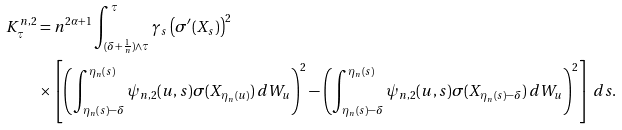Convert formula to latex. <formula><loc_0><loc_0><loc_500><loc_500>K ^ { n , 2 } _ { \tau } & = n ^ { 2 \alpha + 1 } \int ^ { \tau } _ { ( \delta + \frac { 1 } { n } ) \wedge \tau } \gamma _ { s } \left ( \sigma ^ { \prime } ( X _ { s } ) \right ) ^ { 2 } \\ & \times \left [ \left ( \int _ { \eta _ { n } ( s ) - \delta } ^ { \eta _ { n } ( s ) } \psi _ { n , 2 } ( u , s ) \sigma ( X _ { \eta _ { n } ( u ) } ) \, d W _ { u } \right ) ^ { 2 } - \left ( \int _ { \eta _ { n } ( s ) - \delta } ^ { \eta _ { n } ( s ) } \psi _ { n , 2 } ( u , s ) \sigma ( X _ { \eta _ { n } ( s ) - \delta } ) \, d W _ { u } \right ) ^ { 2 } \right ] \, d s .</formula> 